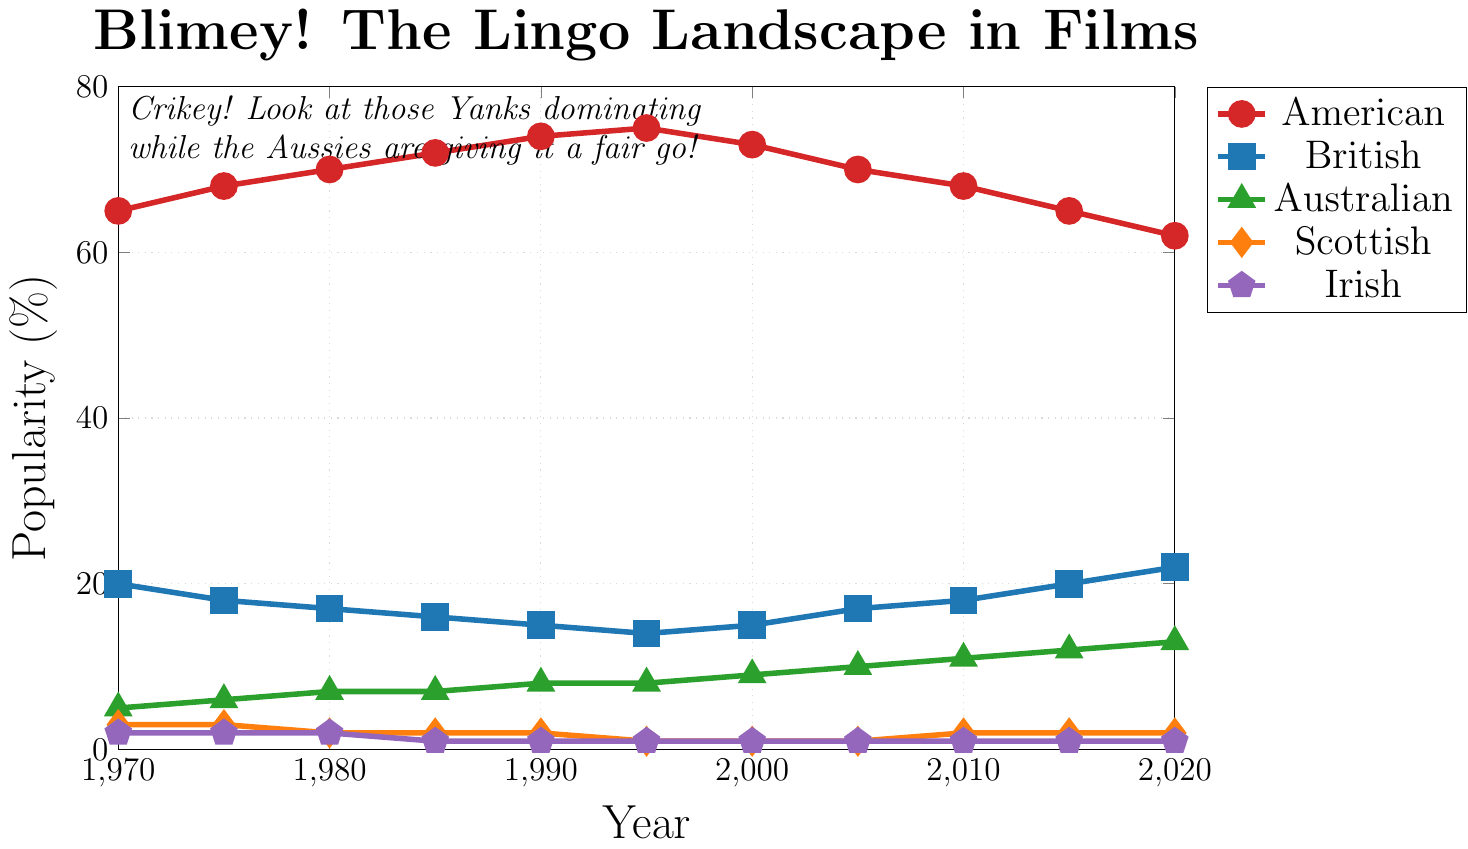Which dialect was the most popular in 1970? To determine the most popular dialect in 1970, we look at the highest value in the 1970 column in the plot. The value of "American" dialect is 65%, which is the highest.
Answer: American How did the popularity of the British dialect change from 1970 to 2020? To track the changes in popularity, we compare the starting and ending values for the British dialect on the timeline. In 1970 it was 20%, and in 2020 it was 22%, indicating a slight increase.
Answer: Increased Which dialects have values that remained constant from 2015 to 2020? By comparing the data points of each dialect between 2015 and 2020, we see that only the Scottish and Irish dialects have the same values (2% and 1%, respectively) for both years.
Answer: Scottish, Irish Which year saw the highest popularity of the American dialect? By visually inspecting the chart, we can observe the peak value for the American dialect on the y-axis over different years. The highest value is 75% in 1995.
Answer: 1995 What is the average popularity of the Australian dialect over the 50-year period? To find the average, add up the popularity values of the Australian dialect from each year and divide by the number of years: (5+6+7+7+8+8+9+10+11+12+13) / 11 = 86 / 11.
Answer: 7.82 What was the trend for the Scottish dialect over the period? Observing the line plot, we note that the Scottish dialect starts at 3% in 1970, decreases to 1% by 1995, and remains constant at 2% or 1% afterward. The overall trend is slightly downward.
Answer: Slightly downward Which dialect showed the most consistent increase in popularity over the years? By examining the slopes of each line plot, the Australian dialect shows a steady and consistent increase in its values from 5% in 1970 to 13% in 2020.
Answer: Australian Compare the popularity changes of the American and British dialects between 1970 and 2020. The American dialect decreased from 65% to 62%, while the British dialect increased from 20% to 22%. This shows that American dialect lost 3%, and British dialect gained 2%.
Answer: American decreased, British increased What change in popularity did the Irish dialect experience between 1985 and 1990? Inspecting the plot at the points for 1985 and 1990, the Irish dialect decreased from 2% in 1985 to 1% in 1990.
Answer: Decreased by 1% 